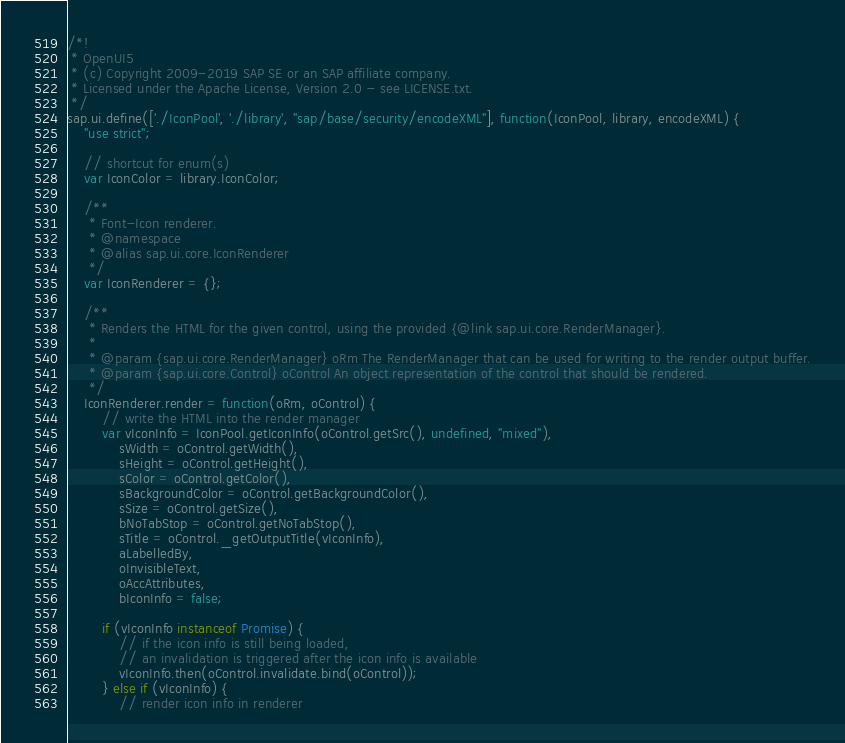<code> <loc_0><loc_0><loc_500><loc_500><_JavaScript_>/*!
 * OpenUI5
 * (c) Copyright 2009-2019 SAP SE or an SAP affiliate company.
 * Licensed under the Apache License, Version 2.0 - see LICENSE.txt.
 */
sap.ui.define(['./IconPool', './library', "sap/base/security/encodeXML"], function(IconPool, library, encodeXML) {
	"use strict";

	// shortcut for enum(s)
	var IconColor = library.IconColor;

	/**
	 * Font-Icon renderer.
	 * @namespace
	 * @alias sap.ui.core.IconRenderer
	 */
	var IconRenderer = {};

	/**
	 * Renders the HTML for the given control, using the provided {@link sap.ui.core.RenderManager}.
	 *
	 * @param {sap.ui.core.RenderManager} oRm The RenderManager that can be used for writing to the render output buffer.
	 * @param {sap.ui.core.Control} oControl An object representation of the control that should be rendered.
	 */
	IconRenderer.render = function(oRm, oControl) {
		// write the HTML into the render manager
		var vIconInfo = IconPool.getIconInfo(oControl.getSrc(), undefined, "mixed"),
			sWidth = oControl.getWidth(),
			sHeight = oControl.getHeight(),
			sColor = oControl.getColor(),
			sBackgroundColor = oControl.getBackgroundColor(),
			sSize = oControl.getSize(),
			bNoTabStop = oControl.getNoTabStop(),
			sTitle = oControl._getOutputTitle(vIconInfo),
			aLabelledBy,
			oInvisibleText,
			oAccAttributes,
			bIconInfo = false;

		if (vIconInfo instanceof Promise) {
			// if the icon info is still being loaded,
			// an invalidation is triggered after the icon info is available
			vIconInfo.then(oControl.invalidate.bind(oControl));
		} else if (vIconInfo) {
			// render icon info in renderer</code> 